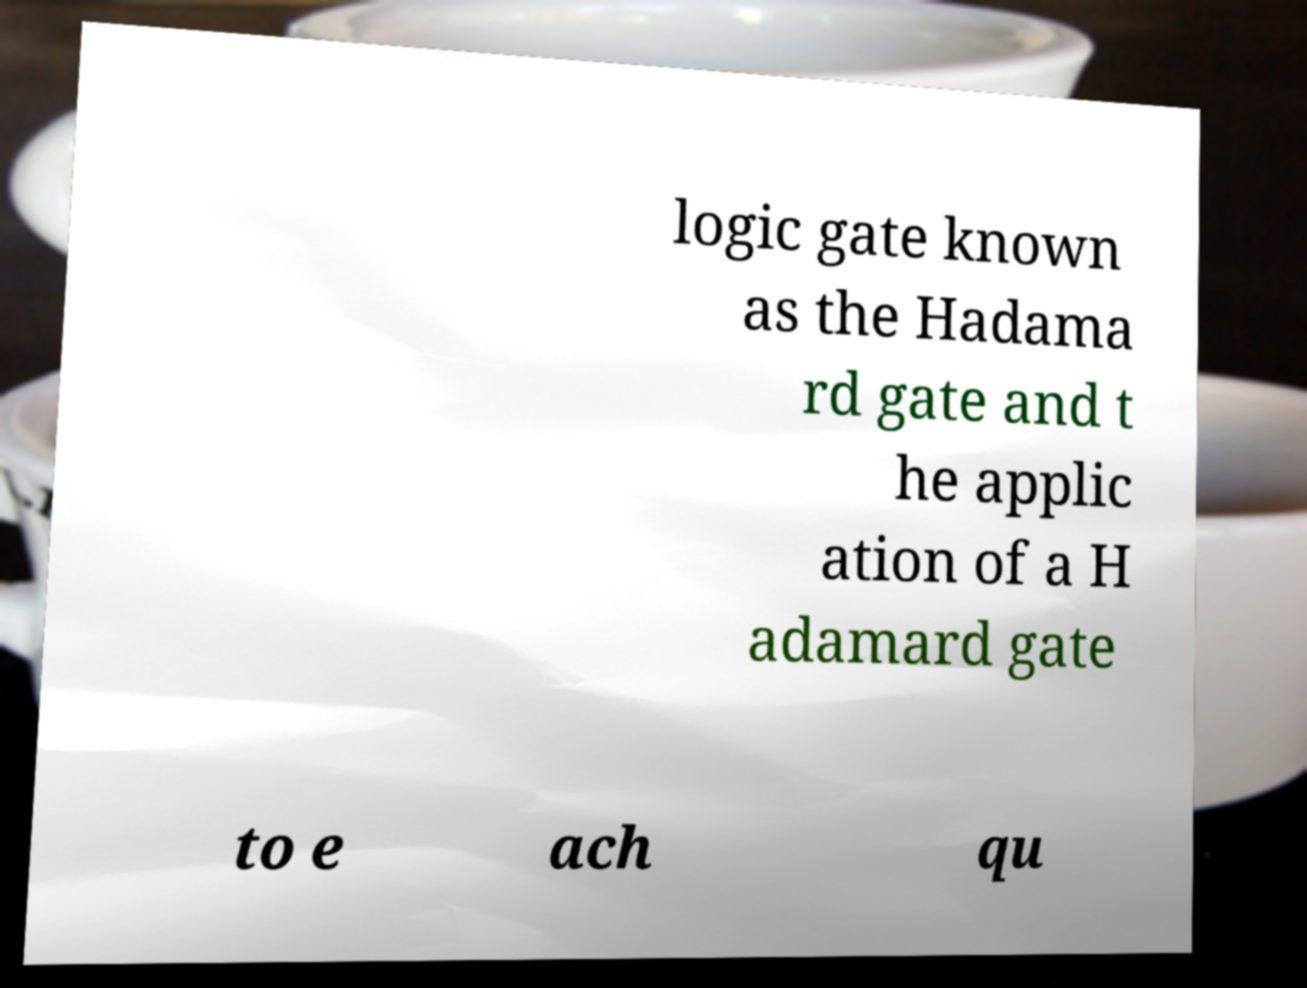There's text embedded in this image that I need extracted. Can you transcribe it verbatim? logic gate known as the Hadama rd gate and t he applic ation of a H adamard gate to e ach qu 